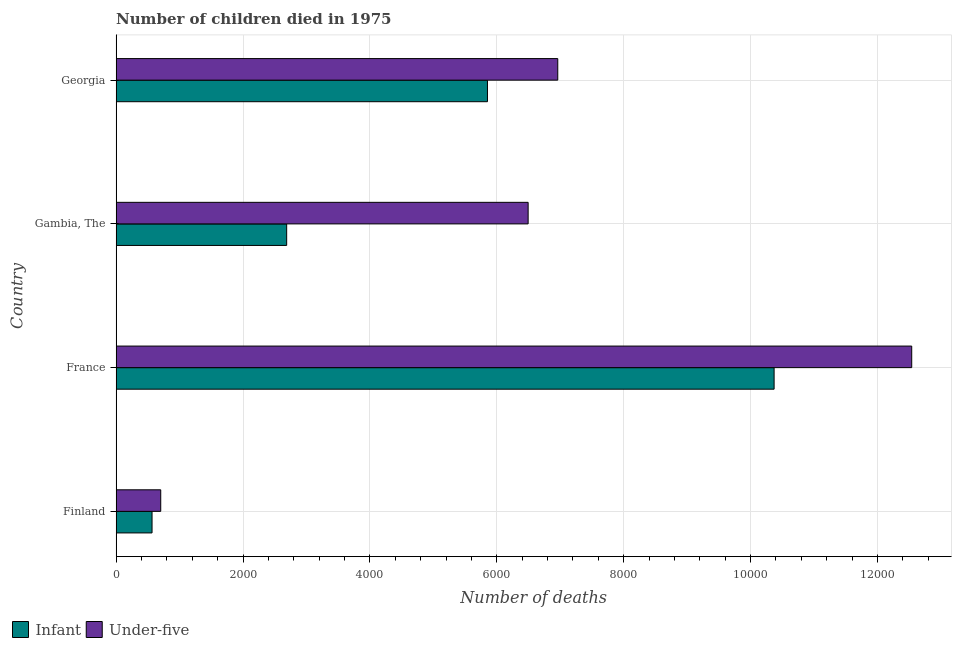How many different coloured bars are there?
Offer a very short reply. 2. How many groups of bars are there?
Provide a short and direct response. 4. How many bars are there on the 3rd tick from the bottom?
Offer a very short reply. 2. What is the label of the 4th group of bars from the top?
Give a very brief answer. Finland. In how many cases, is the number of bars for a given country not equal to the number of legend labels?
Make the answer very short. 0. What is the number of infant deaths in Finland?
Your answer should be very brief. 566. Across all countries, what is the maximum number of infant deaths?
Your answer should be very brief. 1.04e+04. Across all countries, what is the minimum number of infant deaths?
Ensure brevity in your answer.  566. In which country was the number of under-five deaths minimum?
Ensure brevity in your answer.  Finland. What is the total number of under-five deaths in the graph?
Give a very brief answer. 2.67e+04. What is the difference between the number of under-five deaths in France and that in Gambia, The?
Make the answer very short. 6046. What is the difference between the number of infant deaths in Gambia, The and the number of under-five deaths in France?
Make the answer very short. -9852. What is the average number of under-five deaths per country?
Give a very brief answer. 6674.5. What is the difference between the number of infant deaths and number of under-five deaths in France?
Offer a terse response. -2169. What is the ratio of the number of under-five deaths in Gambia, The to that in Georgia?
Offer a terse response. 0.93. Is the number of infant deaths in Finland less than that in Gambia, The?
Offer a very short reply. Yes. What is the difference between the highest and the second highest number of under-five deaths?
Provide a short and direct response. 5579. What is the difference between the highest and the lowest number of infant deaths?
Provide a short and direct response. 9805. In how many countries, is the number of infant deaths greater than the average number of infant deaths taken over all countries?
Give a very brief answer. 2. What does the 1st bar from the top in Gambia, The represents?
Provide a short and direct response. Under-five. What does the 1st bar from the bottom in France represents?
Provide a short and direct response. Infant. How many countries are there in the graph?
Make the answer very short. 4. Are the values on the major ticks of X-axis written in scientific E-notation?
Ensure brevity in your answer.  No. Does the graph contain any zero values?
Your answer should be very brief. No. How many legend labels are there?
Keep it short and to the point. 2. How are the legend labels stacked?
Provide a succinct answer. Horizontal. What is the title of the graph?
Offer a very short reply. Number of children died in 1975. What is the label or title of the X-axis?
Give a very brief answer. Number of deaths. What is the Number of deaths of Infant in Finland?
Provide a short and direct response. 566. What is the Number of deaths in Under-five in Finland?
Make the answer very short. 703. What is the Number of deaths in Infant in France?
Your answer should be very brief. 1.04e+04. What is the Number of deaths of Under-five in France?
Your answer should be very brief. 1.25e+04. What is the Number of deaths in Infant in Gambia, The?
Your answer should be compact. 2688. What is the Number of deaths of Under-five in Gambia, The?
Your response must be concise. 6494. What is the Number of deaths of Infant in Georgia?
Make the answer very short. 5853. What is the Number of deaths in Under-five in Georgia?
Give a very brief answer. 6961. Across all countries, what is the maximum Number of deaths of Infant?
Provide a succinct answer. 1.04e+04. Across all countries, what is the maximum Number of deaths of Under-five?
Your answer should be very brief. 1.25e+04. Across all countries, what is the minimum Number of deaths in Infant?
Make the answer very short. 566. Across all countries, what is the minimum Number of deaths of Under-five?
Your answer should be very brief. 703. What is the total Number of deaths in Infant in the graph?
Provide a short and direct response. 1.95e+04. What is the total Number of deaths of Under-five in the graph?
Offer a very short reply. 2.67e+04. What is the difference between the Number of deaths of Infant in Finland and that in France?
Make the answer very short. -9805. What is the difference between the Number of deaths in Under-five in Finland and that in France?
Your response must be concise. -1.18e+04. What is the difference between the Number of deaths of Infant in Finland and that in Gambia, The?
Your answer should be very brief. -2122. What is the difference between the Number of deaths in Under-five in Finland and that in Gambia, The?
Keep it short and to the point. -5791. What is the difference between the Number of deaths of Infant in Finland and that in Georgia?
Your response must be concise. -5287. What is the difference between the Number of deaths of Under-five in Finland and that in Georgia?
Offer a very short reply. -6258. What is the difference between the Number of deaths of Infant in France and that in Gambia, The?
Give a very brief answer. 7683. What is the difference between the Number of deaths in Under-five in France and that in Gambia, The?
Provide a succinct answer. 6046. What is the difference between the Number of deaths of Infant in France and that in Georgia?
Provide a succinct answer. 4518. What is the difference between the Number of deaths of Under-five in France and that in Georgia?
Provide a short and direct response. 5579. What is the difference between the Number of deaths of Infant in Gambia, The and that in Georgia?
Ensure brevity in your answer.  -3165. What is the difference between the Number of deaths of Under-five in Gambia, The and that in Georgia?
Provide a short and direct response. -467. What is the difference between the Number of deaths in Infant in Finland and the Number of deaths in Under-five in France?
Your response must be concise. -1.20e+04. What is the difference between the Number of deaths of Infant in Finland and the Number of deaths of Under-five in Gambia, The?
Keep it short and to the point. -5928. What is the difference between the Number of deaths in Infant in Finland and the Number of deaths in Under-five in Georgia?
Make the answer very short. -6395. What is the difference between the Number of deaths in Infant in France and the Number of deaths in Under-five in Gambia, The?
Give a very brief answer. 3877. What is the difference between the Number of deaths of Infant in France and the Number of deaths of Under-five in Georgia?
Make the answer very short. 3410. What is the difference between the Number of deaths of Infant in Gambia, The and the Number of deaths of Under-five in Georgia?
Your response must be concise. -4273. What is the average Number of deaths of Infant per country?
Provide a succinct answer. 4869.5. What is the average Number of deaths of Under-five per country?
Provide a succinct answer. 6674.5. What is the difference between the Number of deaths in Infant and Number of deaths in Under-five in Finland?
Your answer should be compact. -137. What is the difference between the Number of deaths in Infant and Number of deaths in Under-five in France?
Offer a very short reply. -2169. What is the difference between the Number of deaths in Infant and Number of deaths in Under-five in Gambia, The?
Your answer should be compact. -3806. What is the difference between the Number of deaths of Infant and Number of deaths of Under-five in Georgia?
Offer a terse response. -1108. What is the ratio of the Number of deaths in Infant in Finland to that in France?
Your answer should be very brief. 0.05. What is the ratio of the Number of deaths of Under-five in Finland to that in France?
Provide a short and direct response. 0.06. What is the ratio of the Number of deaths in Infant in Finland to that in Gambia, The?
Give a very brief answer. 0.21. What is the ratio of the Number of deaths in Under-five in Finland to that in Gambia, The?
Ensure brevity in your answer.  0.11. What is the ratio of the Number of deaths in Infant in Finland to that in Georgia?
Give a very brief answer. 0.1. What is the ratio of the Number of deaths in Under-five in Finland to that in Georgia?
Ensure brevity in your answer.  0.1. What is the ratio of the Number of deaths of Infant in France to that in Gambia, The?
Your answer should be compact. 3.86. What is the ratio of the Number of deaths of Under-five in France to that in Gambia, The?
Your answer should be very brief. 1.93. What is the ratio of the Number of deaths of Infant in France to that in Georgia?
Offer a very short reply. 1.77. What is the ratio of the Number of deaths in Under-five in France to that in Georgia?
Your answer should be very brief. 1.8. What is the ratio of the Number of deaths in Infant in Gambia, The to that in Georgia?
Keep it short and to the point. 0.46. What is the ratio of the Number of deaths of Under-five in Gambia, The to that in Georgia?
Keep it short and to the point. 0.93. What is the difference between the highest and the second highest Number of deaths of Infant?
Provide a succinct answer. 4518. What is the difference between the highest and the second highest Number of deaths of Under-five?
Your answer should be very brief. 5579. What is the difference between the highest and the lowest Number of deaths of Infant?
Your answer should be compact. 9805. What is the difference between the highest and the lowest Number of deaths of Under-five?
Give a very brief answer. 1.18e+04. 